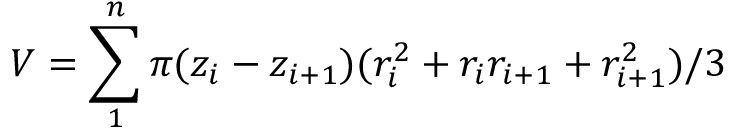Convert formula to latex. <formula><loc_0><loc_0><loc_500><loc_500>V = \sum _ { 1 } ^ { n } \pi ( z _ { i } - z _ { i + 1 } ) ( r _ { i } ^ { 2 } + r _ { i } r _ { i + 1 } + r _ { i + 1 } ^ { 2 } ) / 3</formula> 